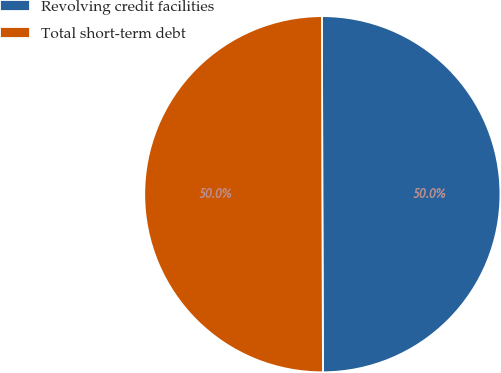<chart> <loc_0><loc_0><loc_500><loc_500><pie_chart><fcel>Revolving credit facilities<fcel>Total short-term debt<nl><fcel>49.98%<fcel>50.02%<nl></chart> 